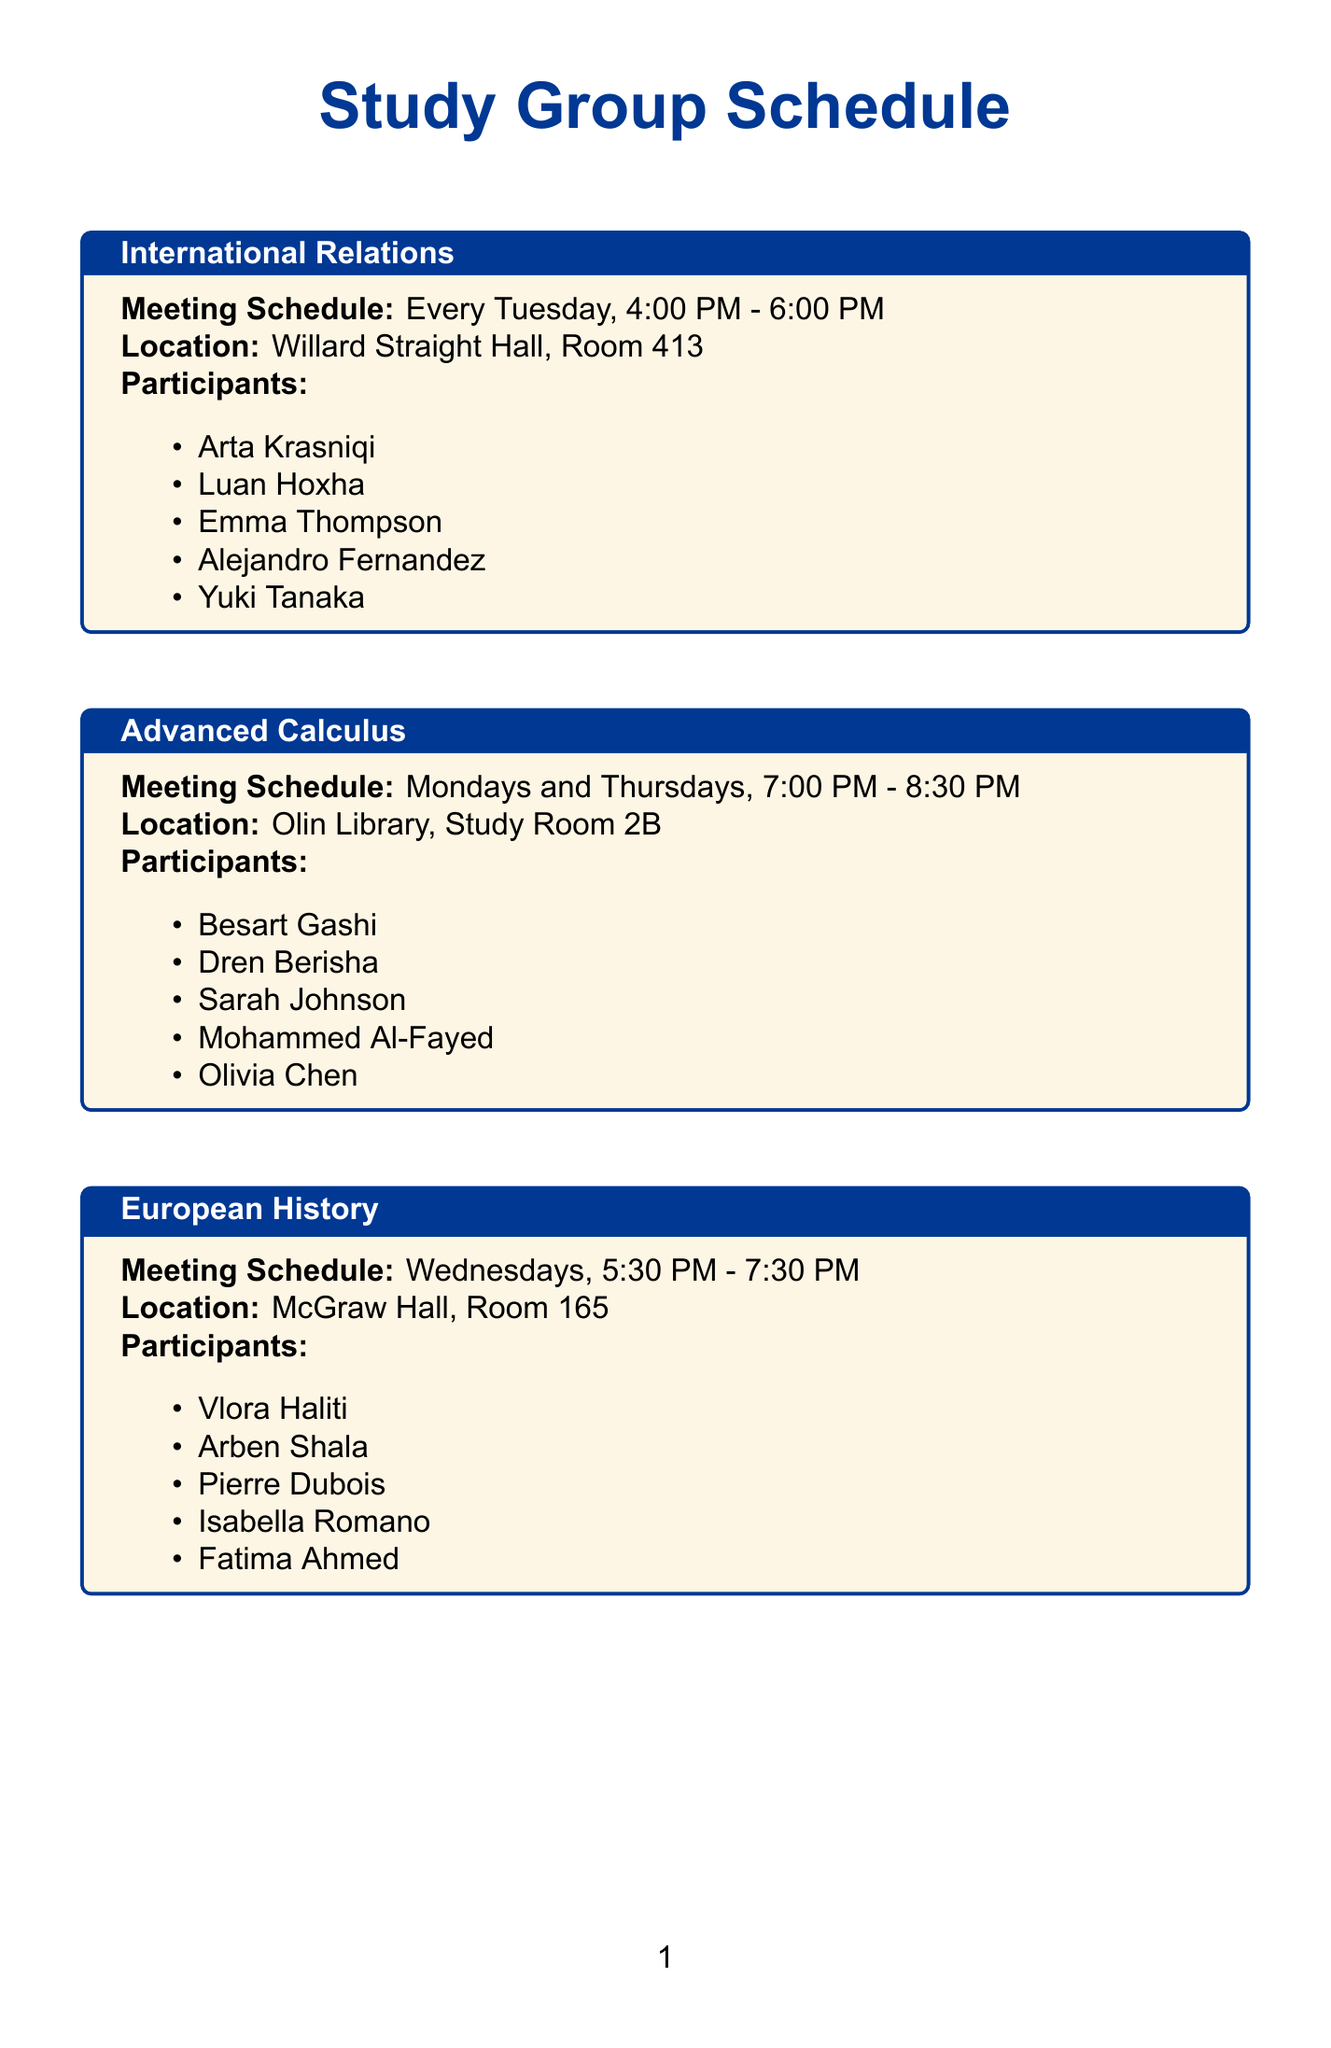What is the meeting schedule for International Relations? The meeting schedule for International Relations is specified in the document.
Answer: Every Tuesday, 4:00 PM - 6:00 PM Who are the participants in Advanced Calculus? The participants listed for Advanced Calculus are provided in the schedule.
Answer: Besart Gashi, Dren Berisha, Sarah Johnson, Mohammed Al-Fayed, Olivia Chen What is the location for the Comparative Literature meetings? The location for Comparative Literature meetings is mentioned in the document.
Answer: Goldwin Smith Hall, Room 236 How many subjects have meetings on Wednesdays? The document specifies the subjects with meetings on Wednesdays, requiring counting from the schedule.
Answer: One Which study group meets every other Saturday? The document states the meeting frequency for each study group.
Answer: Environmental Science What time does the Environmental Science group meet? The time for the Environmental Science meetings is listed in the document.
Answer: 10:00 AM - 12:00 PM How many participants are listed for the European History group? The number of participants listed for European History can be found in the document.
Answer: Five What is the overall structure of the document? The document is organized into sections, each detailing a study group's meeting information.
Answer: Schedule Which participant is in both International Relations and Comparative Literature? This question requires reasoning by checking both participant lists for any overlap.
Answer: None 